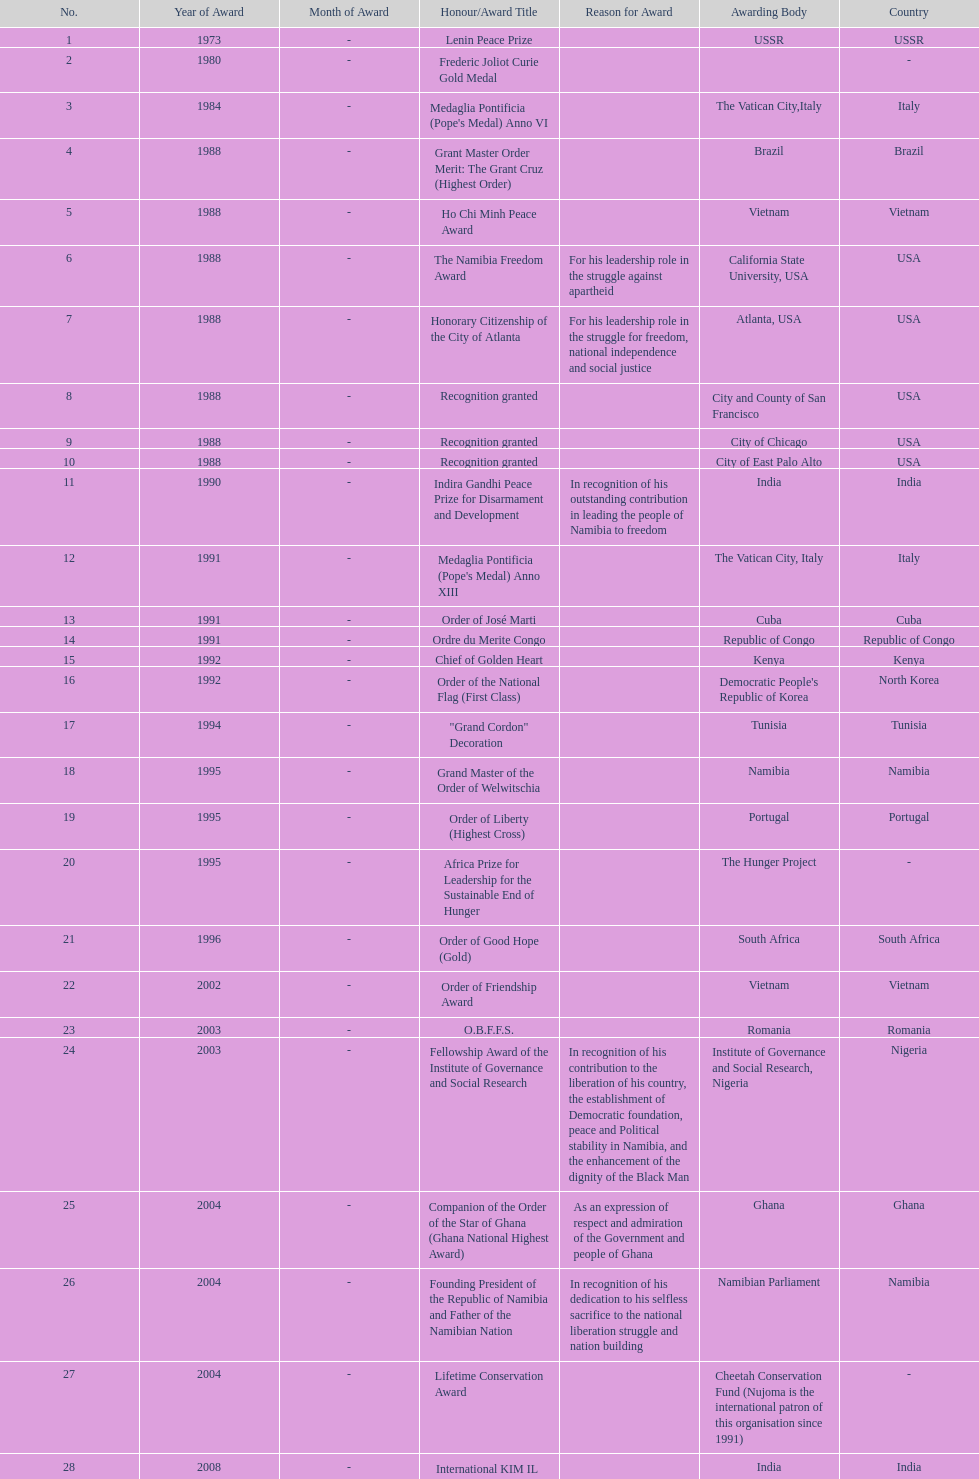Parse the full table. {'header': ['No.', 'Year of Award', 'Month of Award', 'Honour/Award Title', 'Reason for Award', 'Awarding Body', 'Country'], 'rows': [['1', '1973', '-', 'Lenin Peace Prize', '', 'USSR', 'USSR'], ['2', '1980', '-', 'Frederic Joliot Curie Gold Medal', '', '', '-'], ['3', '1984', '-', "Medaglia Pontificia (Pope's Medal) Anno VI", '', 'The Vatican City,Italy', 'Italy'], ['4', '1988', '-', 'Grant Master Order Merit: The Grant Cruz (Highest Order)', '', 'Brazil', 'Brazil'], ['5', '1988', '-', 'Ho Chi Minh Peace Award', '', 'Vietnam', 'Vietnam'], ['6', '1988', '-', 'The Namibia Freedom Award', 'For his leadership role in the struggle against apartheid', 'California State University, USA', 'USA'], ['7', '1988', '-', 'Honorary Citizenship of the City of Atlanta', 'For his leadership role in the struggle for freedom, national independence and social justice', 'Atlanta, USA', 'USA'], ['8', '1988', '-', 'Recognition granted', '', 'City and County of San Francisco', 'USA'], ['9', '1988', '-', 'Recognition granted', '', 'City of Chicago', 'USA'], ['10', '1988', '-', 'Recognition granted', '', 'City of East Palo Alto', 'USA'], ['11', '1990', '-', 'Indira Gandhi Peace Prize for Disarmament and Development', 'In recognition of his outstanding contribution in leading the people of Namibia to freedom', 'India', 'India'], ['12', '1991', '-', "Medaglia Pontificia (Pope's Medal) Anno XIII", '', 'The Vatican City, Italy', 'Italy'], ['13', '1991', '-', 'Order of José Marti', '', 'Cuba', 'Cuba'], ['14', '1991', '-', 'Ordre du Merite Congo', '', 'Republic of Congo', 'Republic of Congo'], ['15', '1992', '-', 'Chief of Golden Heart', '', 'Kenya', 'Kenya'], ['16', '1992', '-', 'Order of the National Flag (First Class)', '', "Democratic People's Republic of Korea", 'North Korea'], ['17', '1994', '-', '"Grand Cordon" Decoration', '', 'Tunisia', 'Tunisia'], ['18', '1995', '-', 'Grand Master of the Order of Welwitschia', '', 'Namibia', 'Namibia'], ['19', '1995', '-', 'Order of Liberty (Highest Cross)', '', 'Portugal', 'Portugal'], ['20', '1995', '-', 'Africa Prize for Leadership for the Sustainable End of Hunger', '', 'The Hunger Project', '-'], ['21', '1996', '-', 'Order of Good Hope (Gold)', '', 'South Africa', 'South Africa'], ['22', '2002', '-', 'Order of Friendship Award', '', 'Vietnam', 'Vietnam'], ['23', '2003', '-', 'O.B.F.F.S.', '', 'Romania', 'Romania'], ['24', '2003', '-', 'Fellowship Award of the Institute of Governance and Social Research', 'In recognition of his contribution to the liberation of his country, the establishment of Democratic foundation, peace and Political stability in Namibia, and the enhancement of the dignity of the Black Man', 'Institute of Governance and Social Research, Nigeria', 'Nigeria'], ['25', '2004', '-', 'Companion of the Order of the Star of Ghana (Ghana National Highest Award)', 'As an expression of respect and admiration of the Government and people of Ghana', 'Ghana', 'Ghana'], ['26', '2004', '-', 'Founding President of the Republic of Namibia and Father of the Namibian Nation', 'In recognition of his dedication to his selfless sacrifice to the national liberation struggle and nation building', 'Namibian Parliament', 'Namibia'], ['27', '2004', '-', 'Lifetime Conservation Award', '', 'Cheetah Conservation Fund (Nujoma is the international patron of this organisation since 1991)', '-'], ['28', '2008', '-', 'International KIM IL Sung Prize Certificate', '', 'India', 'India'], ['29', '2010', '-', 'Sir Seretse Khama SADC Meda', '', 'SADC', 'SADC']]} What is the total number of awards that nujoma won? 29. 